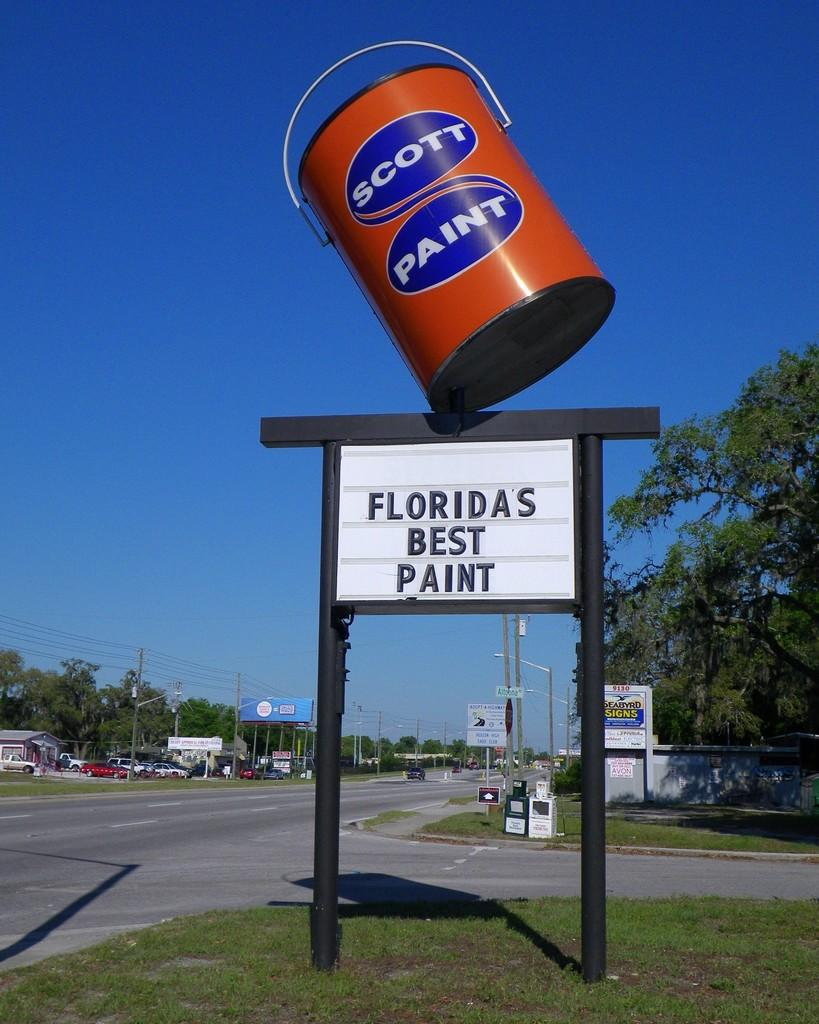<image>
Write a terse but informative summary of the picture. a scott paint object is on a sign 